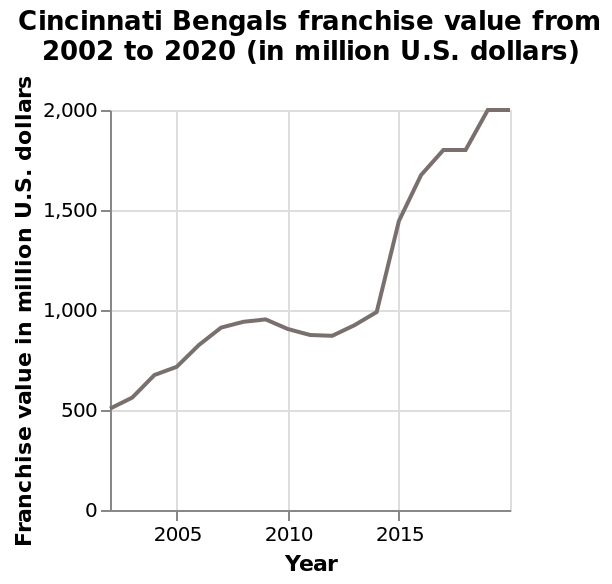<image>
What was the value in 2018? The value flattened in 2018, meaning it remained the same as the previous year - 2000. 